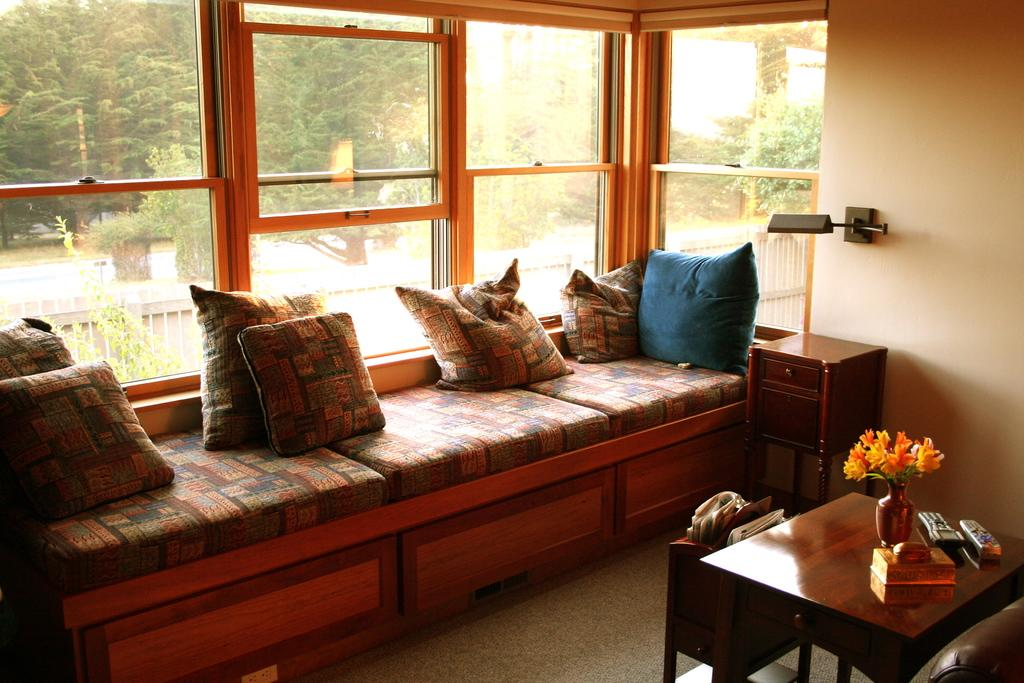What type of natural elements can be seen in the image? There are trees and plants in the image. What type of furniture is present in the image? There is a sofa in the image. What is the purpose of the window in the image? The window provides a view of the natural elements outside. What is placed on the sofa in the image? There are pillows on the sofa. What objects can be seen on the table in the image? There are remotes and a flask on the table. What route should be taken to reach the heart of the image? There is no specific route to reach the heart of the image, as it is not a physical location. What type of vacation is depicted in the image? There is no vacation depicted in the image; it features a sofa, pillows, a table, remotes, and a flask. 